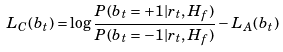Convert formula to latex. <formula><loc_0><loc_0><loc_500><loc_500>L _ { C } ( b _ { t } ) = \log \frac { P ( b _ { t } = + 1 | r _ { t } , H _ { f } ) } { P ( b _ { t } = - 1 | r _ { t } , H _ { f } ) } - L _ { A } ( b _ { t } )</formula> 